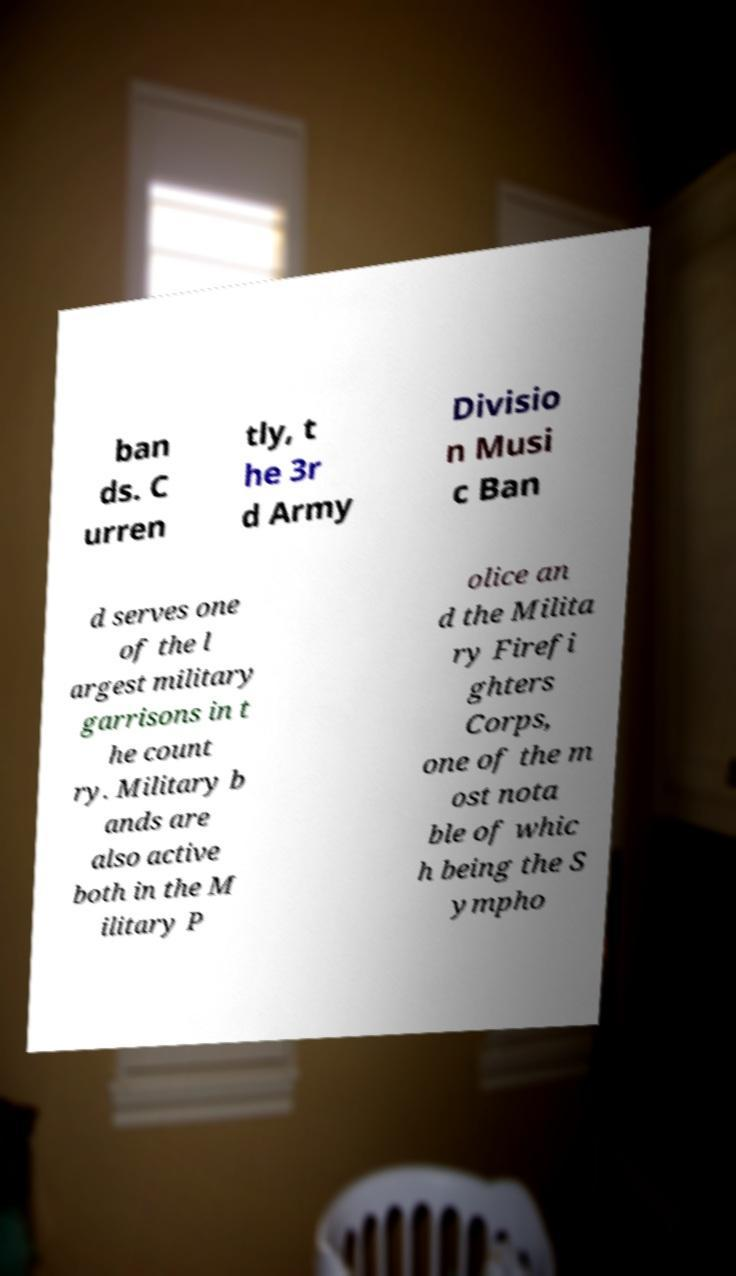Could you assist in decoding the text presented in this image and type it out clearly? ban ds. C urren tly, t he 3r d Army Divisio n Musi c Ban d serves one of the l argest military garrisons in t he count ry. Military b ands are also active both in the M ilitary P olice an d the Milita ry Firefi ghters Corps, one of the m ost nota ble of whic h being the S ympho 